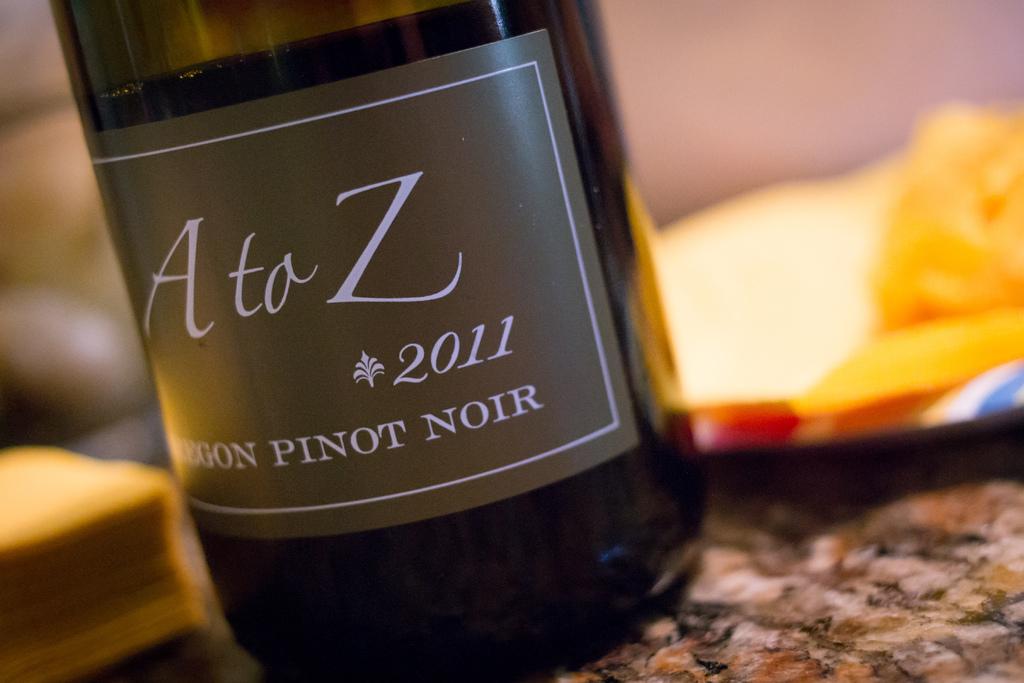Is this a pinot noir?
Offer a terse response. Yes. What year was it bottled?
Ensure brevity in your answer.  2011. 